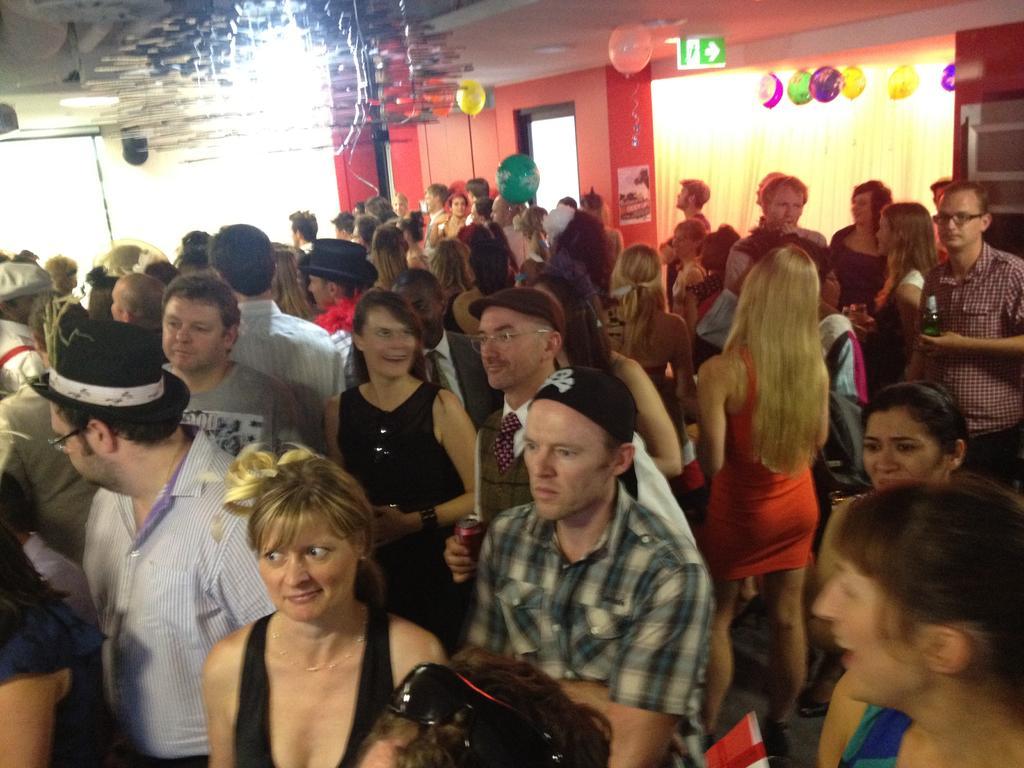How would you summarize this image in a sentence or two? In this image we can see a group of people standing. On the right side we can see holding a bottle. On the backside we can see a wall, balloons with ribbon, a curtain and a roof with some ceiling lights. 